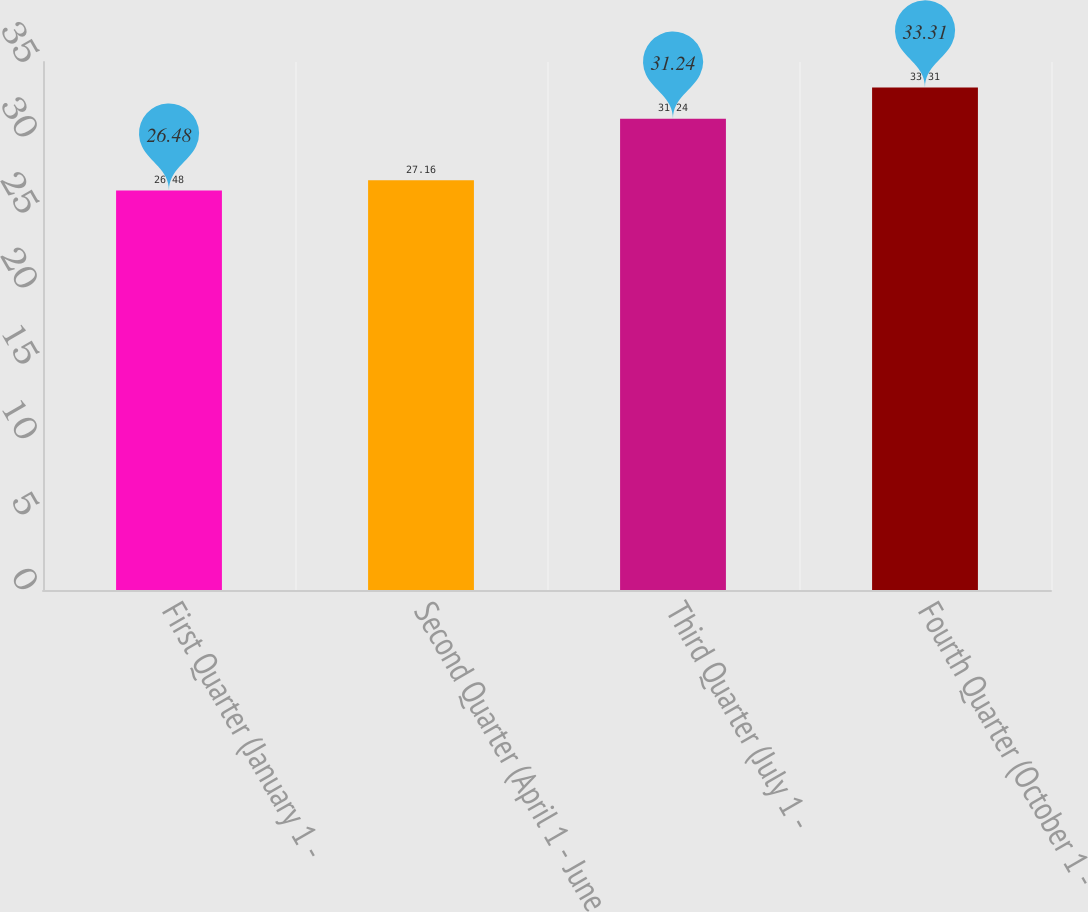<chart> <loc_0><loc_0><loc_500><loc_500><bar_chart><fcel>First Quarter (January 1 -<fcel>Second Quarter (April 1 - June<fcel>Third Quarter (July 1 -<fcel>Fourth Quarter (October 1 -<nl><fcel>26.48<fcel>27.16<fcel>31.24<fcel>33.31<nl></chart> 